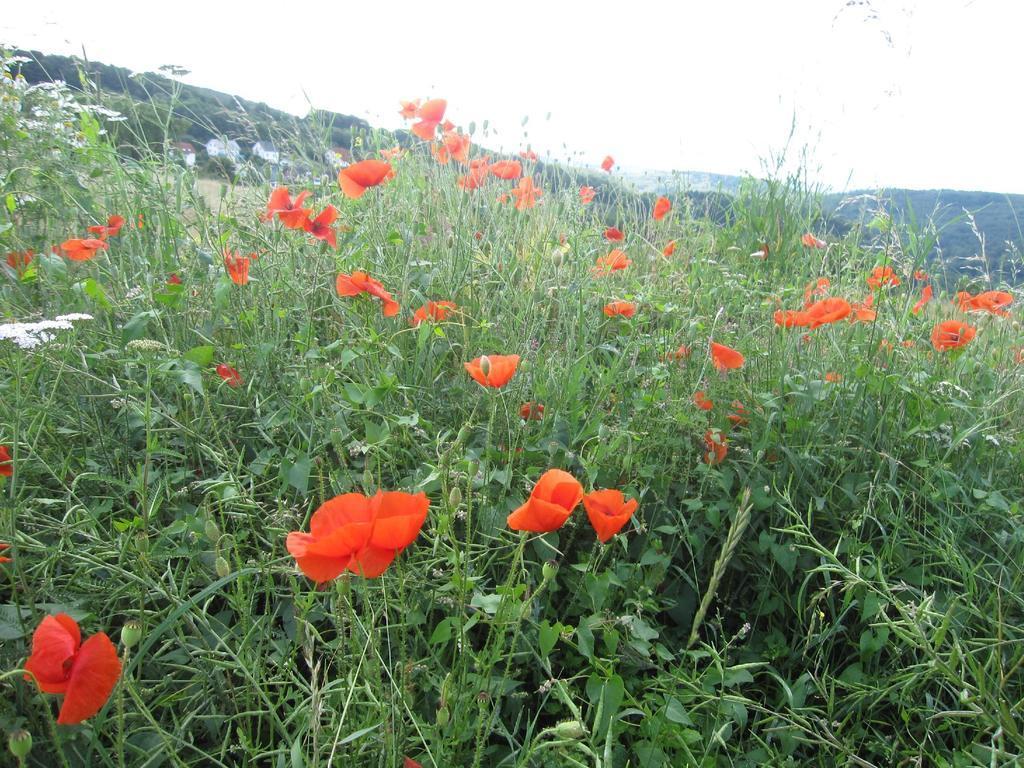In one or two sentences, can you explain what this image depicts? In this image in the foreground there are some plants and flowers, and in the background there are some mountains. 